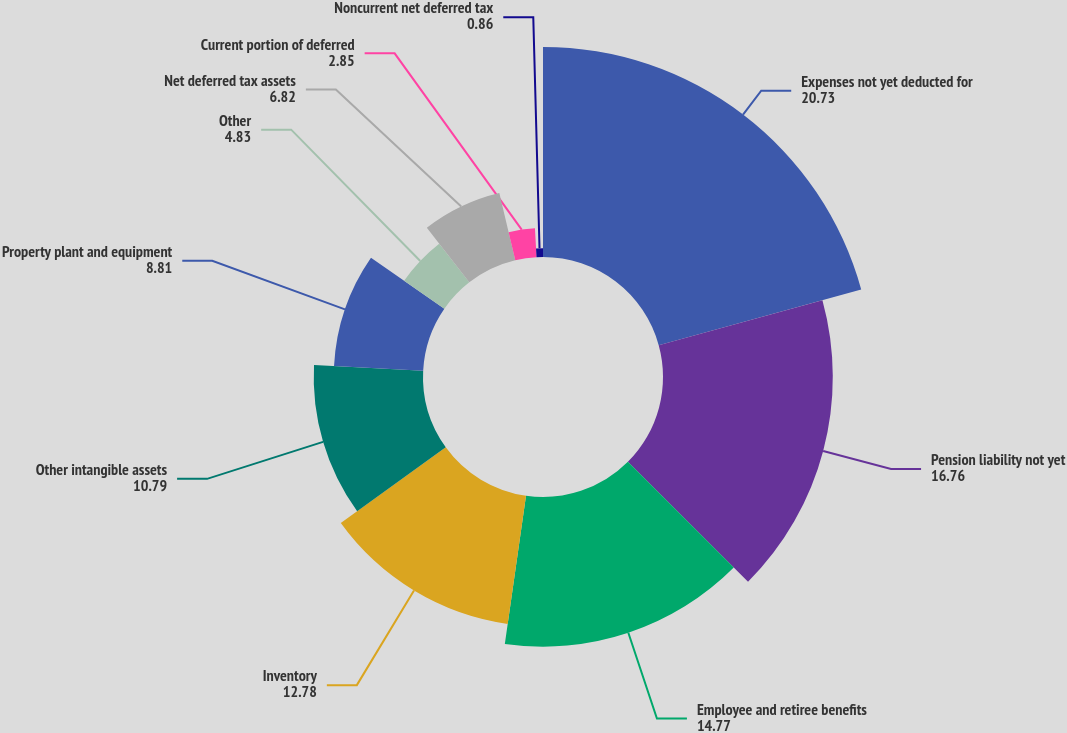Convert chart to OTSL. <chart><loc_0><loc_0><loc_500><loc_500><pie_chart><fcel>Expenses not yet deducted for<fcel>Pension liability not yet<fcel>Employee and retiree benefits<fcel>Inventory<fcel>Other intangible assets<fcel>Property plant and equipment<fcel>Other<fcel>Net deferred tax assets<fcel>Current portion of deferred<fcel>Noncurrent net deferred tax<nl><fcel>20.73%<fcel>16.76%<fcel>14.77%<fcel>12.78%<fcel>10.79%<fcel>8.81%<fcel>4.83%<fcel>6.82%<fcel>2.85%<fcel>0.86%<nl></chart> 